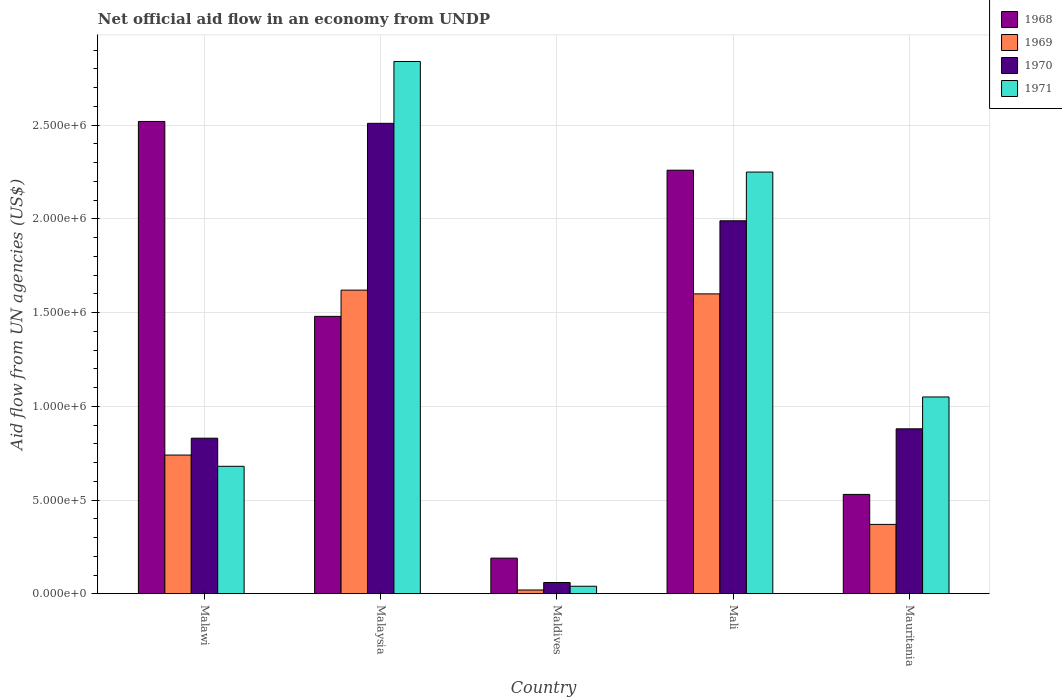How many groups of bars are there?
Keep it short and to the point. 5. Are the number of bars per tick equal to the number of legend labels?
Keep it short and to the point. Yes. What is the label of the 5th group of bars from the left?
Ensure brevity in your answer.  Mauritania. In how many cases, is the number of bars for a given country not equal to the number of legend labels?
Your answer should be compact. 0. What is the net official aid flow in 1971 in Mali?
Make the answer very short. 2.25e+06. Across all countries, what is the maximum net official aid flow in 1970?
Provide a succinct answer. 2.51e+06. In which country was the net official aid flow in 1969 maximum?
Make the answer very short. Malaysia. In which country was the net official aid flow in 1969 minimum?
Offer a very short reply. Maldives. What is the total net official aid flow in 1969 in the graph?
Your response must be concise. 4.35e+06. What is the difference between the net official aid flow in 1970 in Malaysia and that in Mauritania?
Ensure brevity in your answer.  1.63e+06. What is the difference between the net official aid flow in 1970 in Malaysia and the net official aid flow in 1969 in Maldives?
Provide a short and direct response. 2.49e+06. What is the average net official aid flow in 1968 per country?
Your answer should be very brief. 1.40e+06. What is the difference between the net official aid flow of/in 1970 and net official aid flow of/in 1968 in Maldives?
Give a very brief answer. -1.30e+05. What is the ratio of the net official aid flow in 1968 in Malaysia to that in Mauritania?
Keep it short and to the point. 2.79. Is the net official aid flow in 1968 in Malawi less than that in Maldives?
Offer a very short reply. No. What is the difference between the highest and the second highest net official aid flow in 1971?
Provide a succinct answer. 5.90e+05. What is the difference between the highest and the lowest net official aid flow in 1969?
Provide a short and direct response. 1.60e+06. In how many countries, is the net official aid flow in 1970 greater than the average net official aid flow in 1970 taken over all countries?
Ensure brevity in your answer.  2. What does the 2nd bar from the left in Mali represents?
Give a very brief answer. 1969. What does the 4th bar from the right in Maldives represents?
Make the answer very short. 1968. How many bars are there?
Provide a short and direct response. 20. Are all the bars in the graph horizontal?
Provide a short and direct response. No. What is the difference between two consecutive major ticks on the Y-axis?
Provide a succinct answer. 5.00e+05. Are the values on the major ticks of Y-axis written in scientific E-notation?
Ensure brevity in your answer.  Yes. Does the graph contain any zero values?
Ensure brevity in your answer.  No. How many legend labels are there?
Your answer should be compact. 4. How are the legend labels stacked?
Your answer should be very brief. Vertical. What is the title of the graph?
Offer a very short reply. Net official aid flow in an economy from UNDP. Does "1971" appear as one of the legend labels in the graph?
Your answer should be compact. Yes. What is the label or title of the Y-axis?
Make the answer very short. Aid flow from UN agencies (US$). What is the Aid flow from UN agencies (US$) in 1968 in Malawi?
Provide a succinct answer. 2.52e+06. What is the Aid flow from UN agencies (US$) in 1969 in Malawi?
Ensure brevity in your answer.  7.40e+05. What is the Aid flow from UN agencies (US$) of 1970 in Malawi?
Provide a succinct answer. 8.30e+05. What is the Aid flow from UN agencies (US$) in 1971 in Malawi?
Keep it short and to the point. 6.80e+05. What is the Aid flow from UN agencies (US$) of 1968 in Malaysia?
Your answer should be compact. 1.48e+06. What is the Aid flow from UN agencies (US$) of 1969 in Malaysia?
Give a very brief answer. 1.62e+06. What is the Aid flow from UN agencies (US$) in 1970 in Malaysia?
Your response must be concise. 2.51e+06. What is the Aid flow from UN agencies (US$) of 1971 in Malaysia?
Keep it short and to the point. 2.84e+06. What is the Aid flow from UN agencies (US$) of 1968 in Mali?
Your response must be concise. 2.26e+06. What is the Aid flow from UN agencies (US$) in 1969 in Mali?
Offer a very short reply. 1.60e+06. What is the Aid flow from UN agencies (US$) in 1970 in Mali?
Your response must be concise. 1.99e+06. What is the Aid flow from UN agencies (US$) of 1971 in Mali?
Keep it short and to the point. 2.25e+06. What is the Aid flow from UN agencies (US$) in 1968 in Mauritania?
Make the answer very short. 5.30e+05. What is the Aid flow from UN agencies (US$) in 1970 in Mauritania?
Your answer should be compact. 8.80e+05. What is the Aid flow from UN agencies (US$) of 1971 in Mauritania?
Give a very brief answer. 1.05e+06. Across all countries, what is the maximum Aid flow from UN agencies (US$) in 1968?
Your response must be concise. 2.52e+06. Across all countries, what is the maximum Aid flow from UN agencies (US$) in 1969?
Give a very brief answer. 1.62e+06. Across all countries, what is the maximum Aid flow from UN agencies (US$) in 1970?
Provide a short and direct response. 2.51e+06. Across all countries, what is the maximum Aid flow from UN agencies (US$) in 1971?
Provide a succinct answer. 2.84e+06. Across all countries, what is the minimum Aid flow from UN agencies (US$) of 1968?
Offer a very short reply. 1.90e+05. Across all countries, what is the minimum Aid flow from UN agencies (US$) in 1971?
Ensure brevity in your answer.  4.00e+04. What is the total Aid flow from UN agencies (US$) of 1968 in the graph?
Keep it short and to the point. 6.98e+06. What is the total Aid flow from UN agencies (US$) in 1969 in the graph?
Make the answer very short. 4.35e+06. What is the total Aid flow from UN agencies (US$) of 1970 in the graph?
Offer a terse response. 6.27e+06. What is the total Aid flow from UN agencies (US$) of 1971 in the graph?
Make the answer very short. 6.86e+06. What is the difference between the Aid flow from UN agencies (US$) of 1968 in Malawi and that in Malaysia?
Offer a terse response. 1.04e+06. What is the difference between the Aid flow from UN agencies (US$) of 1969 in Malawi and that in Malaysia?
Provide a succinct answer. -8.80e+05. What is the difference between the Aid flow from UN agencies (US$) in 1970 in Malawi and that in Malaysia?
Your response must be concise. -1.68e+06. What is the difference between the Aid flow from UN agencies (US$) of 1971 in Malawi and that in Malaysia?
Your answer should be very brief. -2.16e+06. What is the difference between the Aid flow from UN agencies (US$) of 1968 in Malawi and that in Maldives?
Ensure brevity in your answer.  2.33e+06. What is the difference between the Aid flow from UN agencies (US$) of 1969 in Malawi and that in Maldives?
Provide a short and direct response. 7.20e+05. What is the difference between the Aid flow from UN agencies (US$) in 1970 in Malawi and that in Maldives?
Keep it short and to the point. 7.70e+05. What is the difference between the Aid flow from UN agencies (US$) of 1971 in Malawi and that in Maldives?
Your answer should be very brief. 6.40e+05. What is the difference between the Aid flow from UN agencies (US$) in 1969 in Malawi and that in Mali?
Give a very brief answer. -8.60e+05. What is the difference between the Aid flow from UN agencies (US$) in 1970 in Malawi and that in Mali?
Make the answer very short. -1.16e+06. What is the difference between the Aid flow from UN agencies (US$) in 1971 in Malawi and that in Mali?
Provide a succinct answer. -1.57e+06. What is the difference between the Aid flow from UN agencies (US$) of 1968 in Malawi and that in Mauritania?
Make the answer very short. 1.99e+06. What is the difference between the Aid flow from UN agencies (US$) in 1969 in Malawi and that in Mauritania?
Your answer should be very brief. 3.70e+05. What is the difference between the Aid flow from UN agencies (US$) of 1970 in Malawi and that in Mauritania?
Your answer should be compact. -5.00e+04. What is the difference between the Aid flow from UN agencies (US$) in 1971 in Malawi and that in Mauritania?
Keep it short and to the point. -3.70e+05. What is the difference between the Aid flow from UN agencies (US$) of 1968 in Malaysia and that in Maldives?
Your response must be concise. 1.29e+06. What is the difference between the Aid flow from UN agencies (US$) in 1969 in Malaysia and that in Maldives?
Your answer should be compact. 1.60e+06. What is the difference between the Aid flow from UN agencies (US$) of 1970 in Malaysia and that in Maldives?
Offer a very short reply. 2.45e+06. What is the difference between the Aid flow from UN agencies (US$) in 1971 in Malaysia and that in Maldives?
Offer a very short reply. 2.80e+06. What is the difference between the Aid flow from UN agencies (US$) of 1968 in Malaysia and that in Mali?
Make the answer very short. -7.80e+05. What is the difference between the Aid flow from UN agencies (US$) in 1969 in Malaysia and that in Mali?
Ensure brevity in your answer.  2.00e+04. What is the difference between the Aid flow from UN agencies (US$) in 1970 in Malaysia and that in Mali?
Your answer should be compact. 5.20e+05. What is the difference between the Aid flow from UN agencies (US$) of 1971 in Malaysia and that in Mali?
Your answer should be compact. 5.90e+05. What is the difference between the Aid flow from UN agencies (US$) in 1968 in Malaysia and that in Mauritania?
Ensure brevity in your answer.  9.50e+05. What is the difference between the Aid flow from UN agencies (US$) of 1969 in Malaysia and that in Mauritania?
Ensure brevity in your answer.  1.25e+06. What is the difference between the Aid flow from UN agencies (US$) in 1970 in Malaysia and that in Mauritania?
Your answer should be compact. 1.63e+06. What is the difference between the Aid flow from UN agencies (US$) in 1971 in Malaysia and that in Mauritania?
Offer a very short reply. 1.79e+06. What is the difference between the Aid flow from UN agencies (US$) of 1968 in Maldives and that in Mali?
Your answer should be very brief. -2.07e+06. What is the difference between the Aid flow from UN agencies (US$) in 1969 in Maldives and that in Mali?
Your response must be concise. -1.58e+06. What is the difference between the Aid flow from UN agencies (US$) of 1970 in Maldives and that in Mali?
Provide a succinct answer. -1.93e+06. What is the difference between the Aid flow from UN agencies (US$) of 1971 in Maldives and that in Mali?
Give a very brief answer. -2.21e+06. What is the difference between the Aid flow from UN agencies (US$) of 1968 in Maldives and that in Mauritania?
Ensure brevity in your answer.  -3.40e+05. What is the difference between the Aid flow from UN agencies (US$) in 1969 in Maldives and that in Mauritania?
Give a very brief answer. -3.50e+05. What is the difference between the Aid flow from UN agencies (US$) of 1970 in Maldives and that in Mauritania?
Keep it short and to the point. -8.20e+05. What is the difference between the Aid flow from UN agencies (US$) in 1971 in Maldives and that in Mauritania?
Your response must be concise. -1.01e+06. What is the difference between the Aid flow from UN agencies (US$) of 1968 in Mali and that in Mauritania?
Ensure brevity in your answer.  1.73e+06. What is the difference between the Aid flow from UN agencies (US$) in 1969 in Mali and that in Mauritania?
Ensure brevity in your answer.  1.23e+06. What is the difference between the Aid flow from UN agencies (US$) of 1970 in Mali and that in Mauritania?
Keep it short and to the point. 1.11e+06. What is the difference between the Aid flow from UN agencies (US$) of 1971 in Mali and that in Mauritania?
Your answer should be compact. 1.20e+06. What is the difference between the Aid flow from UN agencies (US$) in 1968 in Malawi and the Aid flow from UN agencies (US$) in 1969 in Malaysia?
Give a very brief answer. 9.00e+05. What is the difference between the Aid flow from UN agencies (US$) in 1968 in Malawi and the Aid flow from UN agencies (US$) in 1970 in Malaysia?
Offer a terse response. 10000. What is the difference between the Aid flow from UN agencies (US$) in 1968 in Malawi and the Aid flow from UN agencies (US$) in 1971 in Malaysia?
Ensure brevity in your answer.  -3.20e+05. What is the difference between the Aid flow from UN agencies (US$) in 1969 in Malawi and the Aid flow from UN agencies (US$) in 1970 in Malaysia?
Provide a succinct answer. -1.77e+06. What is the difference between the Aid flow from UN agencies (US$) of 1969 in Malawi and the Aid flow from UN agencies (US$) of 1971 in Malaysia?
Offer a very short reply. -2.10e+06. What is the difference between the Aid flow from UN agencies (US$) of 1970 in Malawi and the Aid flow from UN agencies (US$) of 1971 in Malaysia?
Your answer should be compact. -2.01e+06. What is the difference between the Aid flow from UN agencies (US$) in 1968 in Malawi and the Aid flow from UN agencies (US$) in 1969 in Maldives?
Keep it short and to the point. 2.50e+06. What is the difference between the Aid flow from UN agencies (US$) in 1968 in Malawi and the Aid flow from UN agencies (US$) in 1970 in Maldives?
Provide a short and direct response. 2.46e+06. What is the difference between the Aid flow from UN agencies (US$) of 1968 in Malawi and the Aid flow from UN agencies (US$) of 1971 in Maldives?
Offer a terse response. 2.48e+06. What is the difference between the Aid flow from UN agencies (US$) of 1969 in Malawi and the Aid flow from UN agencies (US$) of 1970 in Maldives?
Give a very brief answer. 6.80e+05. What is the difference between the Aid flow from UN agencies (US$) of 1970 in Malawi and the Aid flow from UN agencies (US$) of 1971 in Maldives?
Make the answer very short. 7.90e+05. What is the difference between the Aid flow from UN agencies (US$) in 1968 in Malawi and the Aid flow from UN agencies (US$) in 1969 in Mali?
Ensure brevity in your answer.  9.20e+05. What is the difference between the Aid flow from UN agencies (US$) of 1968 in Malawi and the Aid flow from UN agencies (US$) of 1970 in Mali?
Keep it short and to the point. 5.30e+05. What is the difference between the Aid flow from UN agencies (US$) of 1968 in Malawi and the Aid flow from UN agencies (US$) of 1971 in Mali?
Make the answer very short. 2.70e+05. What is the difference between the Aid flow from UN agencies (US$) in 1969 in Malawi and the Aid flow from UN agencies (US$) in 1970 in Mali?
Provide a short and direct response. -1.25e+06. What is the difference between the Aid flow from UN agencies (US$) in 1969 in Malawi and the Aid flow from UN agencies (US$) in 1971 in Mali?
Provide a succinct answer. -1.51e+06. What is the difference between the Aid flow from UN agencies (US$) of 1970 in Malawi and the Aid flow from UN agencies (US$) of 1971 in Mali?
Your response must be concise. -1.42e+06. What is the difference between the Aid flow from UN agencies (US$) of 1968 in Malawi and the Aid flow from UN agencies (US$) of 1969 in Mauritania?
Keep it short and to the point. 2.15e+06. What is the difference between the Aid flow from UN agencies (US$) in 1968 in Malawi and the Aid flow from UN agencies (US$) in 1970 in Mauritania?
Offer a terse response. 1.64e+06. What is the difference between the Aid flow from UN agencies (US$) of 1968 in Malawi and the Aid flow from UN agencies (US$) of 1971 in Mauritania?
Keep it short and to the point. 1.47e+06. What is the difference between the Aid flow from UN agencies (US$) of 1969 in Malawi and the Aid flow from UN agencies (US$) of 1971 in Mauritania?
Keep it short and to the point. -3.10e+05. What is the difference between the Aid flow from UN agencies (US$) of 1970 in Malawi and the Aid flow from UN agencies (US$) of 1971 in Mauritania?
Give a very brief answer. -2.20e+05. What is the difference between the Aid flow from UN agencies (US$) of 1968 in Malaysia and the Aid flow from UN agencies (US$) of 1969 in Maldives?
Offer a terse response. 1.46e+06. What is the difference between the Aid flow from UN agencies (US$) of 1968 in Malaysia and the Aid flow from UN agencies (US$) of 1970 in Maldives?
Make the answer very short. 1.42e+06. What is the difference between the Aid flow from UN agencies (US$) in 1968 in Malaysia and the Aid flow from UN agencies (US$) in 1971 in Maldives?
Provide a succinct answer. 1.44e+06. What is the difference between the Aid flow from UN agencies (US$) in 1969 in Malaysia and the Aid flow from UN agencies (US$) in 1970 in Maldives?
Your answer should be very brief. 1.56e+06. What is the difference between the Aid flow from UN agencies (US$) of 1969 in Malaysia and the Aid flow from UN agencies (US$) of 1971 in Maldives?
Make the answer very short. 1.58e+06. What is the difference between the Aid flow from UN agencies (US$) in 1970 in Malaysia and the Aid flow from UN agencies (US$) in 1971 in Maldives?
Provide a short and direct response. 2.47e+06. What is the difference between the Aid flow from UN agencies (US$) in 1968 in Malaysia and the Aid flow from UN agencies (US$) in 1969 in Mali?
Offer a terse response. -1.20e+05. What is the difference between the Aid flow from UN agencies (US$) in 1968 in Malaysia and the Aid flow from UN agencies (US$) in 1970 in Mali?
Provide a short and direct response. -5.10e+05. What is the difference between the Aid flow from UN agencies (US$) in 1968 in Malaysia and the Aid flow from UN agencies (US$) in 1971 in Mali?
Your answer should be very brief. -7.70e+05. What is the difference between the Aid flow from UN agencies (US$) in 1969 in Malaysia and the Aid flow from UN agencies (US$) in 1970 in Mali?
Keep it short and to the point. -3.70e+05. What is the difference between the Aid flow from UN agencies (US$) in 1969 in Malaysia and the Aid flow from UN agencies (US$) in 1971 in Mali?
Keep it short and to the point. -6.30e+05. What is the difference between the Aid flow from UN agencies (US$) of 1968 in Malaysia and the Aid flow from UN agencies (US$) of 1969 in Mauritania?
Offer a terse response. 1.11e+06. What is the difference between the Aid flow from UN agencies (US$) of 1968 in Malaysia and the Aid flow from UN agencies (US$) of 1970 in Mauritania?
Offer a terse response. 6.00e+05. What is the difference between the Aid flow from UN agencies (US$) in 1968 in Malaysia and the Aid flow from UN agencies (US$) in 1971 in Mauritania?
Offer a very short reply. 4.30e+05. What is the difference between the Aid flow from UN agencies (US$) in 1969 in Malaysia and the Aid flow from UN agencies (US$) in 1970 in Mauritania?
Ensure brevity in your answer.  7.40e+05. What is the difference between the Aid flow from UN agencies (US$) of 1969 in Malaysia and the Aid flow from UN agencies (US$) of 1971 in Mauritania?
Offer a very short reply. 5.70e+05. What is the difference between the Aid flow from UN agencies (US$) in 1970 in Malaysia and the Aid flow from UN agencies (US$) in 1971 in Mauritania?
Provide a short and direct response. 1.46e+06. What is the difference between the Aid flow from UN agencies (US$) in 1968 in Maldives and the Aid flow from UN agencies (US$) in 1969 in Mali?
Your response must be concise. -1.41e+06. What is the difference between the Aid flow from UN agencies (US$) in 1968 in Maldives and the Aid flow from UN agencies (US$) in 1970 in Mali?
Offer a very short reply. -1.80e+06. What is the difference between the Aid flow from UN agencies (US$) in 1968 in Maldives and the Aid flow from UN agencies (US$) in 1971 in Mali?
Keep it short and to the point. -2.06e+06. What is the difference between the Aid flow from UN agencies (US$) of 1969 in Maldives and the Aid flow from UN agencies (US$) of 1970 in Mali?
Provide a short and direct response. -1.97e+06. What is the difference between the Aid flow from UN agencies (US$) of 1969 in Maldives and the Aid flow from UN agencies (US$) of 1971 in Mali?
Give a very brief answer. -2.23e+06. What is the difference between the Aid flow from UN agencies (US$) of 1970 in Maldives and the Aid flow from UN agencies (US$) of 1971 in Mali?
Offer a terse response. -2.19e+06. What is the difference between the Aid flow from UN agencies (US$) in 1968 in Maldives and the Aid flow from UN agencies (US$) in 1970 in Mauritania?
Offer a very short reply. -6.90e+05. What is the difference between the Aid flow from UN agencies (US$) in 1968 in Maldives and the Aid flow from UN agencies (US$) in 1971 in Mauritania?
Offer a terse response. -8.60e+05. What is the difference between the Aid flow from UN agencies (US$) of 1969 in Maldives and the Aid flow from UN agencies (US$) of 1970 in Mauritania?
Offer a very short reply. -8.60e+05. What is the difference between the Aid flow from UN agencies (US$) of 1969 in Maldives and the Aid flow from UN agencies (US$) of 1971 in Mauritania?
Your response must be concise. -1.03e+06. What is the difference between the Aid flow from UN agencies (US$) of 1970 in Maldives and the Aid flow from UN agencies (US$) of 1971 in Mauritania?
Offer a terse response. -9.90e+05. What is the difference between the Aid flow from UN agencies (US$) of 1968 in Mali and the Aid flow from UN agencies (US$) of 1969 in Mauritania?
Make the answer very short. 1.89e+06. What is the difference between the Aid flow from UN agencies (US$) in 1968 in Mali and the Aid flow from UN agencies (US$) in 1970 in Mauritania?
Your answer should be compact. 1.38e+06. What is the difference between the Aid flow from UN agencies (US$) in 1968 in Mali and the Aid flow from UN agencies (US$) in 1971 in Mauritania?
Your answer should be compact. 1.21e+06. What is the difference between the Aid flow from UN agencies (US$) in 1969 in Mali and the Aid flow from UN agencies (US$) in 1970 in Mauritania?
Offer a terse response. 7.20e+05. What is the difference between the Aid flow from UN agencies (US$) in 1970 in Mali and the Aid flow from UN agencies (US$) in 1971 in Mauritania?
Give a very brief answer. 9.40e+05. What is the average Aid flow from UN agencies (US$) in 1968 per country?
Ensure brevity in your answer.  1.40e+06. What is the average Aid flow from UN agencies (US$) in 1969 per country?
Your response must be concise. 8.70e+05. What is the average Aid flow from UN agencies (US$) in 1970 per country?
Ensure brevity in your answer.  1.25e+06. What is the average Aid flow from UN agencies (US$) in 1971 per country?
Keep it short and to the point. 1.37e+06. What is the difference between the Aid flow from UN agencies (US$) in 1968 and Aid flow from UN agencies (US$) in 1969 in Malawi?
Provide a short and direct response. 1.78e+06. What is the difference between the Aid flow from UN agencies (US$) of 1968 and Aid flow from UN agencies (US$) of 1970 in Malawi?
Your answer should be compact. 1.69e+06. What is the difference between the Aid flow from UN agencies (US$) in 1968 and Aid flow from UN agencies (US$) in 1971 in Malawi?
Offer a terse response. 1.84e+06. What is the difference between the Aid flow from UN agencies (US$) of 1969 and Aid flow from UN agencies (US$) of 1971 in Malawi?
Offer a terse response. 6.00e+04. What is the difference between the Aid flow from UN agencies (US$) of 1970 and Aid flow from UN agencies (US$) of 1971 in Malawi?
Ensure brevity in your answer.  1.50e+05. What is the difference between the Aid flow from UN agencies (US$) in 1968 and Aid flow from UN agencies (US$) in 1970 in Malaysia?
Provide a short and direct response. -1.03e+06. What is the difference between the Aid flow from UN agencies (US$) in 1968 and Aid flow from UN agencies (US$) in 1971 in Malaysia?
Make the answer very short. -1.36e+06. What is the difference between the Aid flow from UN agencies (US$) of 1969 and Aid flow from UN agencies (US$) of 1970 in Malaysia?
Provide a succinct answer. -8.90e+05. What is the difference between the Aid flow from UN agencies (US$) of 1969 and Aid flow from UN agencies (US$) of 1971 in Malaysia?
Your answer should be very brief. -1.22e+06. What is the difference between the Aid flow from UN agencies (US$) of 1970 and Aid flow from UN agencies (US$) of 1971 in Malaysia?
Offer a terse response. -3.30e+05. What is the difference between the Aid flow from UN agencies (US$) of 1968 and Aid flow from UN agencies (US$) of 1969 in Maldives?
Your answer should be compact. 1.70e+05. What is the difference between the Aid flow from UN agencies (US$) of 1968 and Aid flow from UN agencies (US$) of 1970 in Maldives?
Give a very brief answer. 1.30e+05. What is the difference between the Aid flow from UN agencies (US$) of 1968 and Aid flow from UN agencies (US$) of 1971 in Maldives?
Offer a very short reply. 1.50e+05. What is the difference between the Aid flow from UN agencies (US$) of 1969 and Aid flow from UN agencies (US$) of 1971 in Maldives?
Ensure brevity in your answer.  -2.00e+04. What is the difference between the Aid flow from UN agencies (US$) of 1969 and Aid flow from UN agencies (US$) of 1970 in Mali?
Your response must be concise. -3.90e+05. What is the difference between the Aid flow from UN agencies (US$) in 1969 and Aid flow from UN agencies (US$) in 1971 in Mali?
Your answer should be very brief. -6.50e+05. What is the difference between the Aid flow from UN agencies (US$) of 1970 and Aid flow from UN agencies (US$) of 1971 in Mali?
Your answer should be compact. -2.60e+05. What is the difference between the Aid flow from UN agencies (US$) in 1968 and Aid flow from UN agencies (US$) in 1969 in Mauritania?
Make the answer very short. 1.60e+05. What is the difference between the Aid flow from UN agencies (US$) in 1968 and Aid flow from UN agencies (US$) in 1970 in Mauritania?
Offer a terse response. -3.50e+05. What is the difference between the Aid flow from UN agencies (US$) in 1968 and Aid flow from UN agencies (US$) in 1971 in Mauritania?
Your response must be concise. -5.20e+05. What is the difference between the Aid flow from UN agencies (US$) of 1969 and Aid flow from UN agencies (US$) of 1970 in Mauritania?
Your answer should be compact. -5.10e+05. What is the difference between the Aid flow from UN agencies (US$) of 1969 and Aid flow from UN agencies (US$) of 1971 in Mauritania?
Provide a succinct answer. -6.80e+05. What is the difference between the Aid flow from UN agencies (US$) in 1970 and Aid flow from UN agencies (US$) in 1971 in Mauritania?
Provide a short and direct response. -1.70e+05. What is the ratio of the Aid flow from UN agencies (US$) in 1968 in Malawi to that in Malaysia?
Provide a succinct answer. 1.7. What is the ratio of the Aid flow from UN agencies (US$) of 1969 in Malawi to that in Malaysia?
Make the answer very short. 0.46. What is the ratio of the Aid flow from UN agencies (US$) of 1970 in Malawi to that in Malaysia?
Your answer should be very brief. 0.33. What is the ratio of the Aid flow from UN agencies (US$) in 1971 in Malawi to that in Malaysia?
Ensure brevity in your answer.  0.24. What is the ratio of the Aid flow from UN agencies (US$) in 1968 in Malawi to that in Maldives?
Your answer should be compact. 13.26. What is the ratio of the Aid flow from UN agencies (US$) of 1969 in Malawi to that in Maldives?
Provide a succinct answer. 37. What is the ratio of the Aid flow from UN agencies (US$) of 1970 in Malawi to that in Maldives?
Offer a terse response. 13.83. What is the ratio of the Aid flow from UN agencies (US$) of 1971 in Malawi to that in Maldives?
Provide a short and direct response. 17. What is the ratio of the Aid flow from UN agencies (US$) in 1968 in Malawi to that in Mali?
Make the answer very short. 1.11. What is the ratio of the Aid flow from UN agencies (US$) of 1969 in Malawi to that in Mali?
Offer a terse response. 0.46. What is the ratio of the Aid flow from UN agencies (US$) in 1970 in Malawi to that in Mali?
Ensure brevity in your answer.  0.42. What is the ratio of the Aid flow from UN agencies (US$) of 1971 in Malawi to that in Mali?
Offer a terse response. 0.3. What is the ratio of the Aid flow from UN agencies (US$) of 1968 in Malawi to that in Mauritania?
Make the answer very short. 4.75. What is the ratio of the Aid flow from UN agencies (US$) in 1970 in Malawi to that in Mauritania?
Your answer should be very brief. 0.94. What is the ratio of the Aid flow from UN agencies (US$) in 1971 in Malawi to that in Mauritania?
Give a very brief answer. 0.65. What is the ratio of the Aid flow from UN agencies (US$) in 1968 in Malaysia to that in Maldives?
Provide a short and direct response. 7.79. What is the ratio of the Aid flow from UN agencies (US$) in 1970 in Malaysia to that in Maldives?
Make the answer very short. 41.83. What is the ratio of the Aid flow from UN agencies (US$) in 1968 in Malaysia to that in Mali?
Provide a succinct answer. 0.65. What is the ratio of the Aid flow from UN agencies (US$) in 1969 in Malaysia to that in Mali?
Your response must be concise. 1.01. What is the ratio of the Aid flow from UN agencies (US$) in 1970 in Malaysia to that in Mali?
Ensure brevity in your answer.  1.26. What is the ratio of the Aid flow from UN agencies (US$) of 1971 in Malaysia to that in Mali?
Offer a terse response. 1.26. What is the ratio of the Aid flow from UN agencies (US$) in 1968 in Malaysia to that in Mauritania?
Provide a short and direct response. 2.79. What is the ratio of the Aid flow from UN agencies (US$) of 1969 in Malaysia to that in Mauritania?
Ensure brevity in your answer.  4.38. What is the ratio of the Aid flow from UN agencies (US$) in 1970 in Malaysia to that in Mauritania?
Offer a terse response. 2.85. What is the ratio of the Aid flow from UN agencies (US$) in 1971 in Malaysia to that in Mauritania?
Keep it short and to the point. 2.7. What is the ratio of the Aid flow from UN agencies (US$) of 1968 in Maldives to that in Mali?
Ensure brevity in your answer.  0.08. What is the ratio of the Aid flow from UN agencies (US$) of 1969 in Maldives to that in Mali?
Offer a very short reply. 0.01. What is the ratio of the Aid flow from UN agencies (US$) in 1970 in Maldives to that in Mali?
Make the answer very short. 0.03. What is the ratio of the Aid flow from UN agencies (US$) of 1971 in Maldives to that in Mali?
Your answer should be very brief. 0.02. What is the ratio of the Aid flow from UN agencies (US$) of 1968 in Maldives to that in Mauritania?
Offer a terse response. 0.36. What is the ratio of the Aid flow from UN agencies (US$) of 1969 in Maldives to that in Mauritania?
Give a very brief answer. 0.05. What is the ratio of the Aid flow from UN agencies (US$) in 1970 in Maldives to that in Mauritania?
Make the answer very short. 0.07. What is the ratio of the Aid flow from UN agencies (US$) of 1971 in Maldives to that in Mauritania?
Your answer should be compact. 0.04. What is the ratio of the Aid flow from UN agencies (US$) in 1968 in Mali to that in Mauritania?
Provide a succinct answer. 4.26. What is the ratio of the Aid flow from UN agencies (US$) of 1969 in Mali to that in Mauritania?
Your response must be concise. 4.32. What is the ratio of the Aid flow from UN agencies (US$) in 1970 in Mali to that in Mauritania?
Give a very brief answer. 2.26. What is the ratio of the Aid flow from UN agencies (US$) in 1971 in Mali to that in Mauritania?
Provide a short and direct response. 2.14. What is the difference between the highest and the second highest Aid flow from UN agencies (US$) in 1969?
Your answer should be compact. 2.00e+04. What is the difference between the highest and the second highest Aid flow from UN agencies (US$) in 1970?
Make the answer very short. 5.20e+05. What is the difference between the highest and the second highest Aid flow from UN agencies (US$) in 1971?
Offer a very short reply. 5.90e+05. What is the difference between the highest and the lowest Aid flow from UN agencies (US$) in 1968?
Your answer should be compact. 2.33e+06. What is the difference between the highest and the lowest Aid flow from UN agencies (US$) of 1969?
Provide a short and direct response. 1.60e+06. What is the difference between the highest and the lowest Aid flow from UN agencies (US$) of 1970?
Keep it short and to the point. 2.45e+06. What is the difference between the highest and the lowest Aid flow from UN agencies (US$) in 1971?
Make the answer very short. 2.80e+06. 